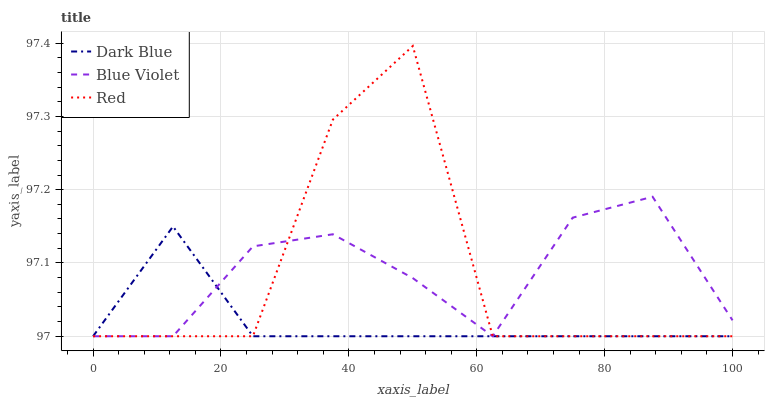Does Dark Blue have the minimum area under the curve?
Answer yes or no. Yes. Does Blue Violet have the maximum area under the curve?
Answer yes or no. Yes. Does Red have the minimum area under the curve?
Answer yes or no. No. Does Red have the maximum area under the curve?
Answer yes or no. No. Is Dark Blue the smoothest?
Answer yes or no. Yes. Is Red the roughest?
Answer yes or no. Yes. Is Blue Violet the smoothest?
Answer yes or no. No. Is Blue Violet the roughest?
Answer yes or no. No. Does Dark Blue have the lowest value?
Answer yes or no. Yes. Does Red have the highest value?
Answer yes or no. Yes. Does Blue Violet have the highest value?
Answer yes or no. No. Does Blue Violet intersect Red?
Answer yes or no. Yes. Is Blue Violet less than Red?
Answer yes or no. No. Is Blue Violet greater than Red?
Answer yes or no. No. 